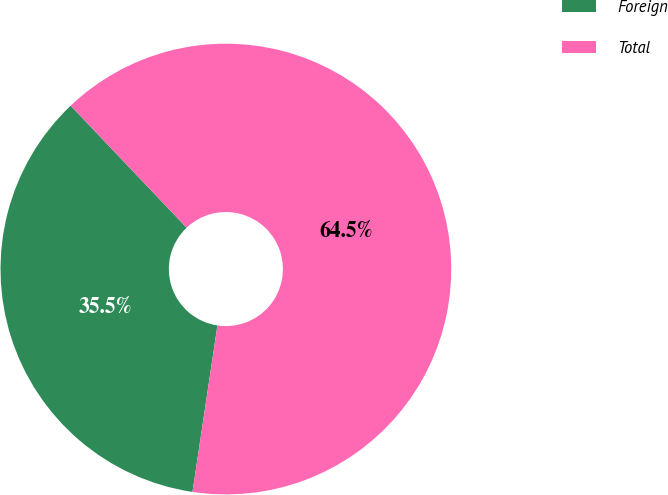Convert chart to OTSL. <chart><loc_0><loc_0><loc_500><loc_500><pie_chart><fcel>Foreign<fcel>Total<nl><fcel>35.54%<fcel>64.46%<nl></chart> 